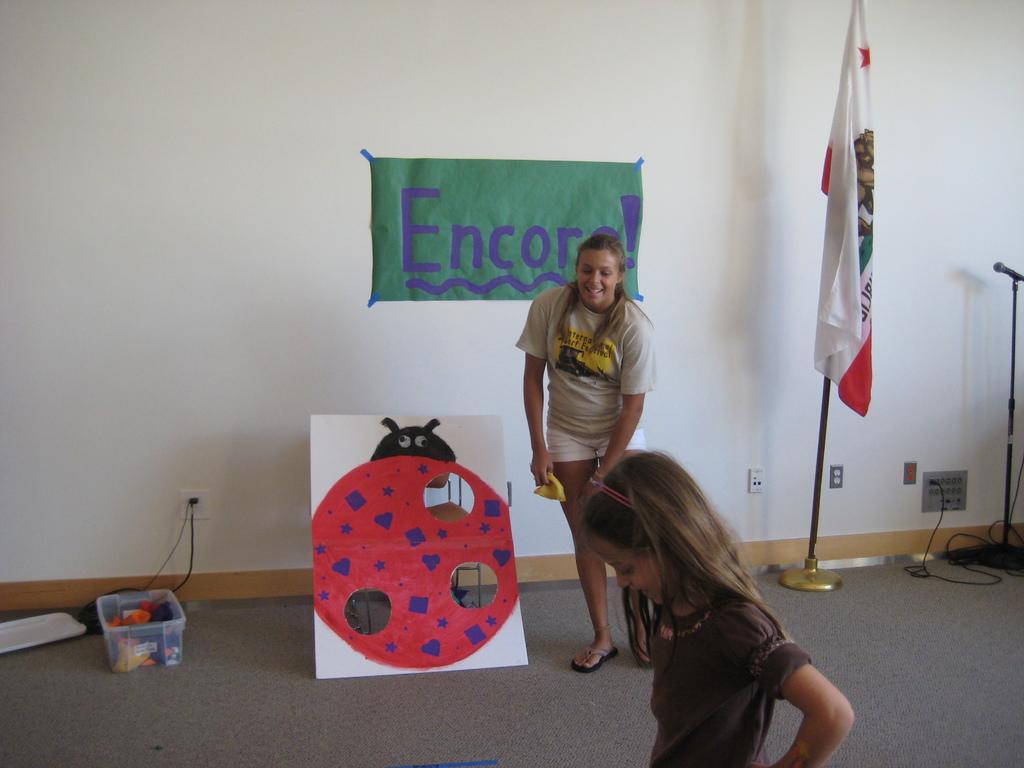Could you give a brief overview of what you see in this image? In this image we can see a woman and a child standing on the floor, container, cables, flag, flag post, mic, mic stand, electric shaft, paper with some text pasted on the wall and a craft. 